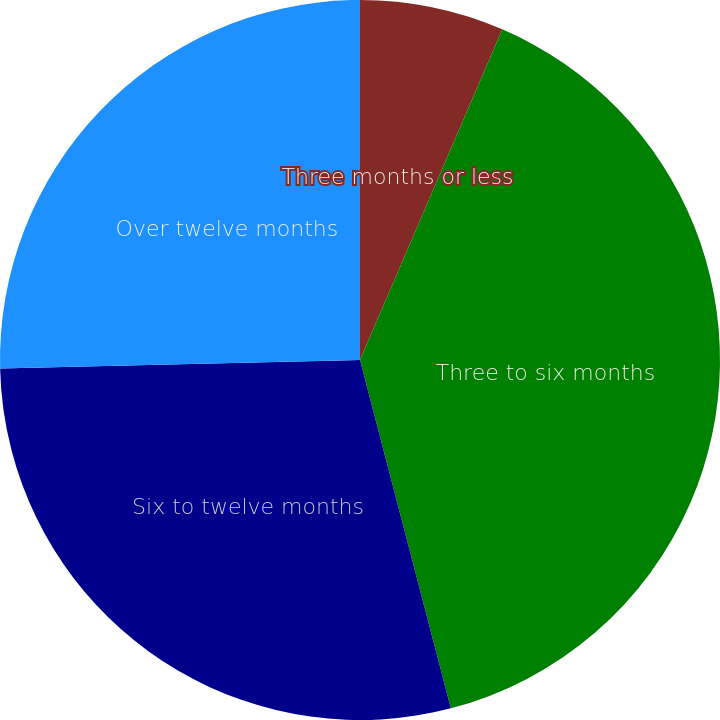<chart> <loc_0><loc_0><loc_500><loc_500><pie_chart><fcel>Three months or less<fcel>Three to six months<fcel>Six to twelve months<fcel>Over twelve months<nl><fcel>6.47%<fcel>39.47%<fcel>28.68%<fcel>25.38%<nl></chart> 